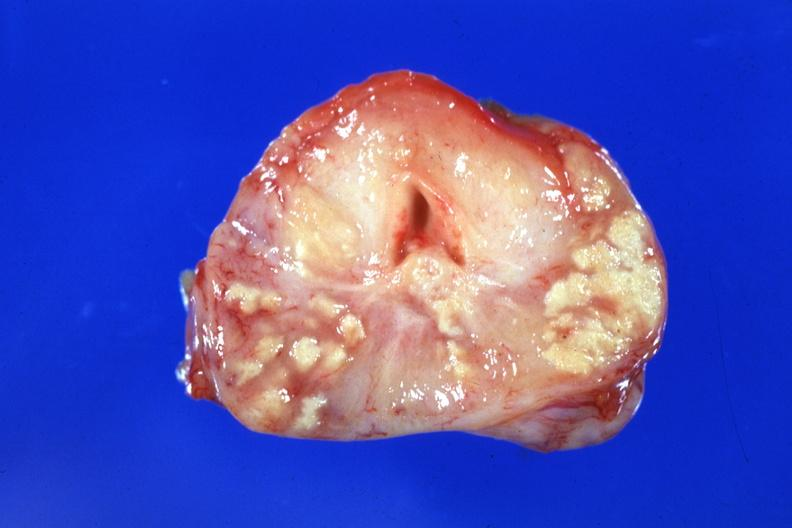s tuberculosis present?
Answer the question using a single word or phrase. Yes 